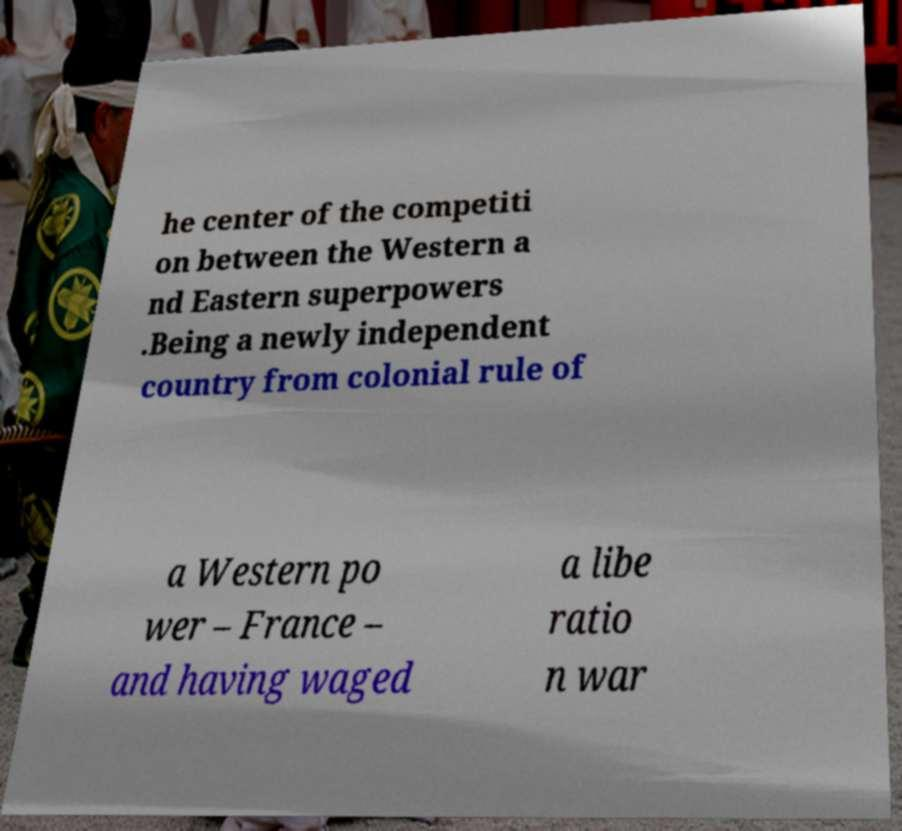There's text embedded in this image that I need extracted. Can you transcribe it verbatim? he center of the competiti on between the Western a nd Eastern superpowers .Being a newly independent country from colonial rule of a Western po wer – France – and having waged a libe ratio n war 